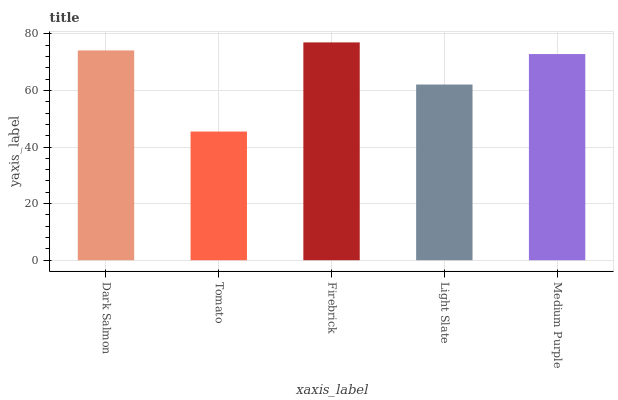Is Firebrick the minimum?
Answer yes or no. No. Is Tomato the maximum?
Answer yes or no. No. Is Firebrick greater than Tomato?
Answer yes or no. Yes. Is Tomato less than Firebrick?
Answer yes or no. Yes. Is Tomato greater than Firebrick?
Answer yes or no. No. Is Firebrick less than Tomato?
Answer yes or no. No. Is Medium Purple the high median?
Answer yes or no. Yes. Is Medium Purple the low median?
Answer yes or no. Yes. Is Light Slate the high median?
Answer yes or no. No. Is Tomato the low median?
Answer yes or no. No. 